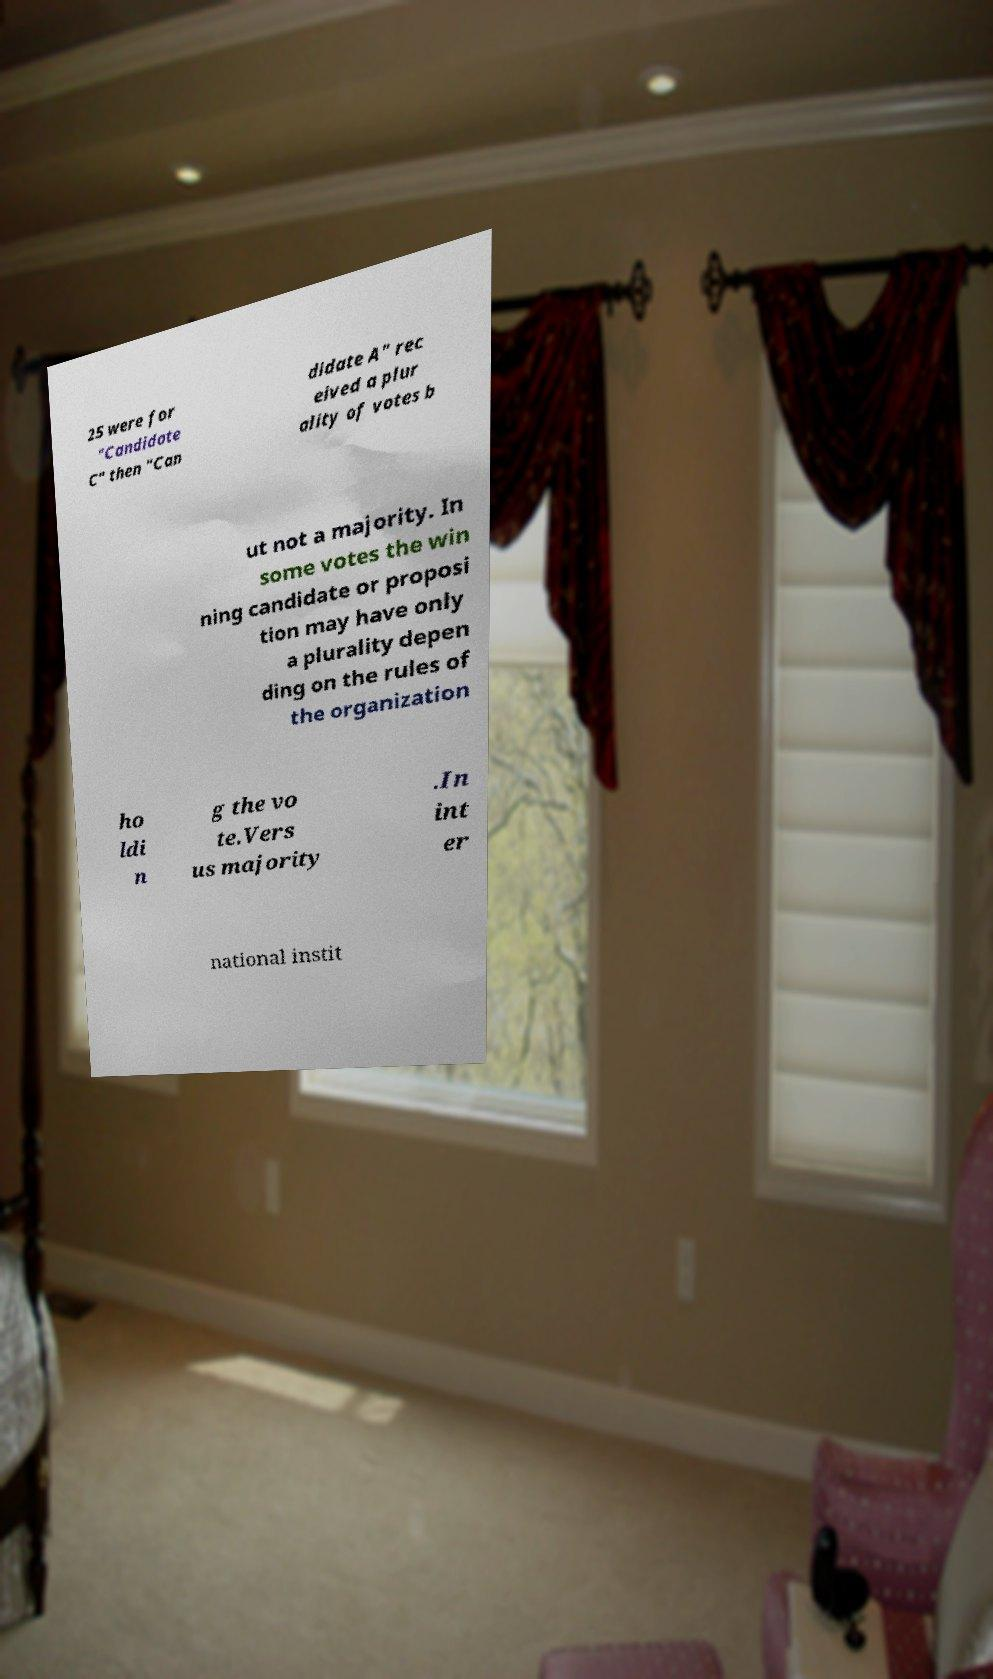What messages or text are displayed in this image? I need them in a readable, typed format. 25 were for "Candidate C" then "Can didate A" rec eived a plur ality of votes b ut not a majority. In some votes the win ning candidate or proposi tion may have only a plurality depen ding on the rules of the organization ho ldi n g the vo te.Vers us majority .In int er national instit 